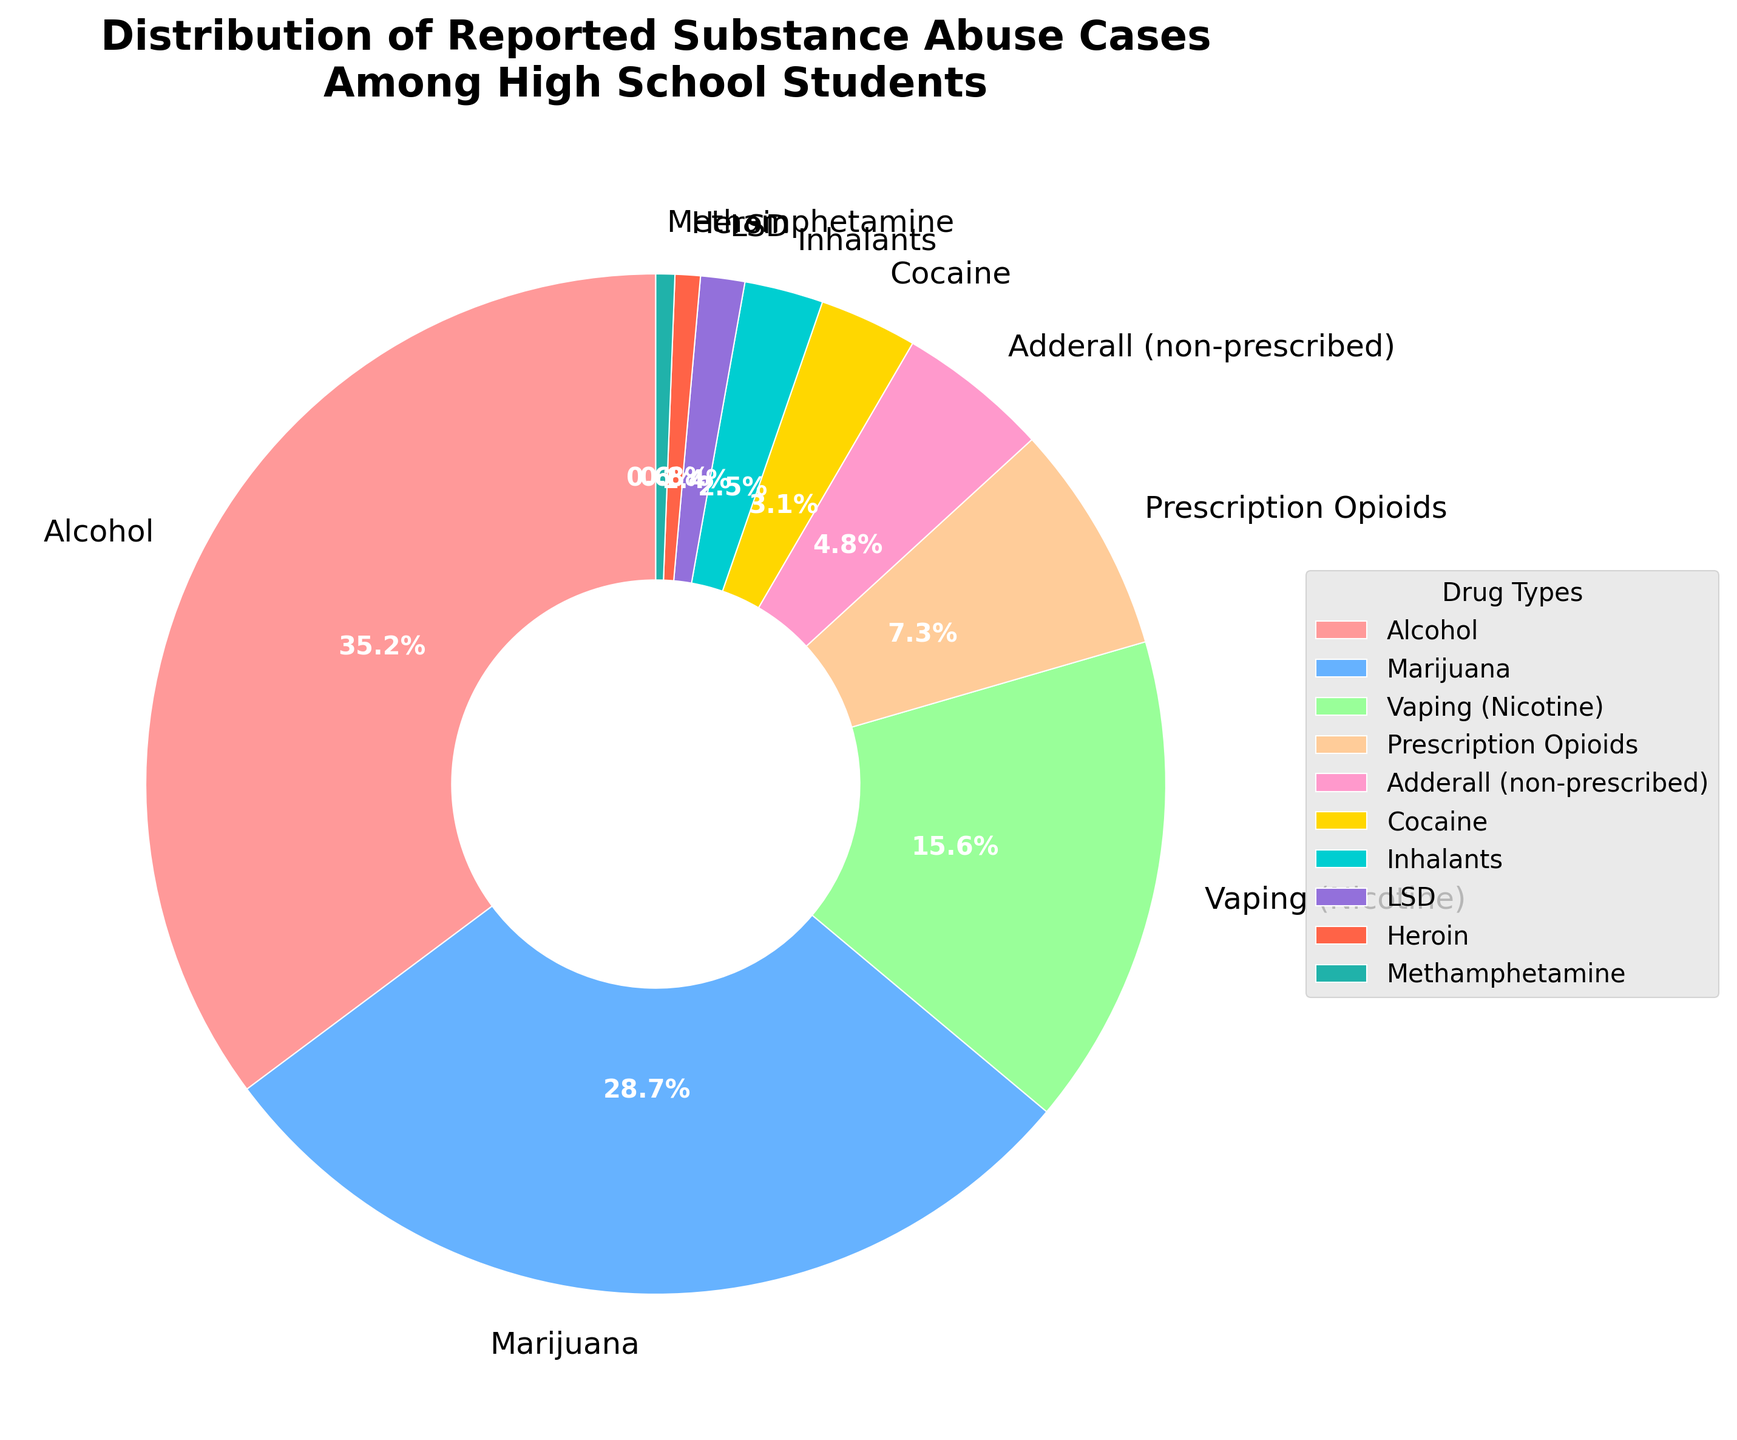Which drug type has the highest percentage of reported substance abuse cases? The segment with the largest size indicates the highest percentage. Alcohol has the largest segment.
Answer: Alcohol What is the combined percentage of reported cases for Marijuana and Vaping (Nicotine)? The percentage for Marijuana is 28.7% and for Vaping (Nicotine) is 15.6%. Adding these gives 28.7 + 15.6 = 44.3.
Answer: 44.3% Which drug has a lower reported percentage, Cocaine or Prescription Opioids? The visually smaller segment corresponds to a lower percentage. Cocaine is shown as 3.1%, and Prescription Opioids is 7.3%. Hence, Cocaine has a lower percentage.
Answer: Cocaine Sum the percentages of the drugs each accounting for less than 5% of reported cases. The drugs are Adderall (non-prescribed) 4.8%, Cocaine 3.1%, Inhalants 2.5%, LSD 1.4%, Heroin 0.8%, and Methamphetamine 0.6%. Adding these gives 4.8 + 3.1 + 2.5 + 1.4 + 0.8 + 0.6 = 13.2.
Answer: 13.2% How much higher is the percentage of Alcohol compared to Marijuana? Alcohol is 35.2% and Marijuana is 28.7%. The difference is 35.2 - 28.7 = 6.5.
Answer: 6.5% Rank the top three drug types based on reported substance abuse cases. The three largest segments indicate the highest percentages. The top three are Alcohol 35.2%, Marijuana 28.7%, and Vaping (Nicotine) 15.6%.
Answer: Alcohol, Marijuana, Vaping (Nicotine) Which two drugs have reported cases closest in percentage? Compare segments to find the most similar sizes. Prescription Opioids (7.3%) and Adderall (non-prescribed) (4.8%) with the difference being 2.5 are the closest.
Answer: Prescription Opioids and Adderall (non-prescribed) Is the percentage of reported cases for Heroin greater than for Methamphetamine? Check the segments for Heroin 0.8% and Methamphetamine 0.6%. Since 0.8% > 0.6%, the percentage for Heroin is greater.
Answer: Yes 